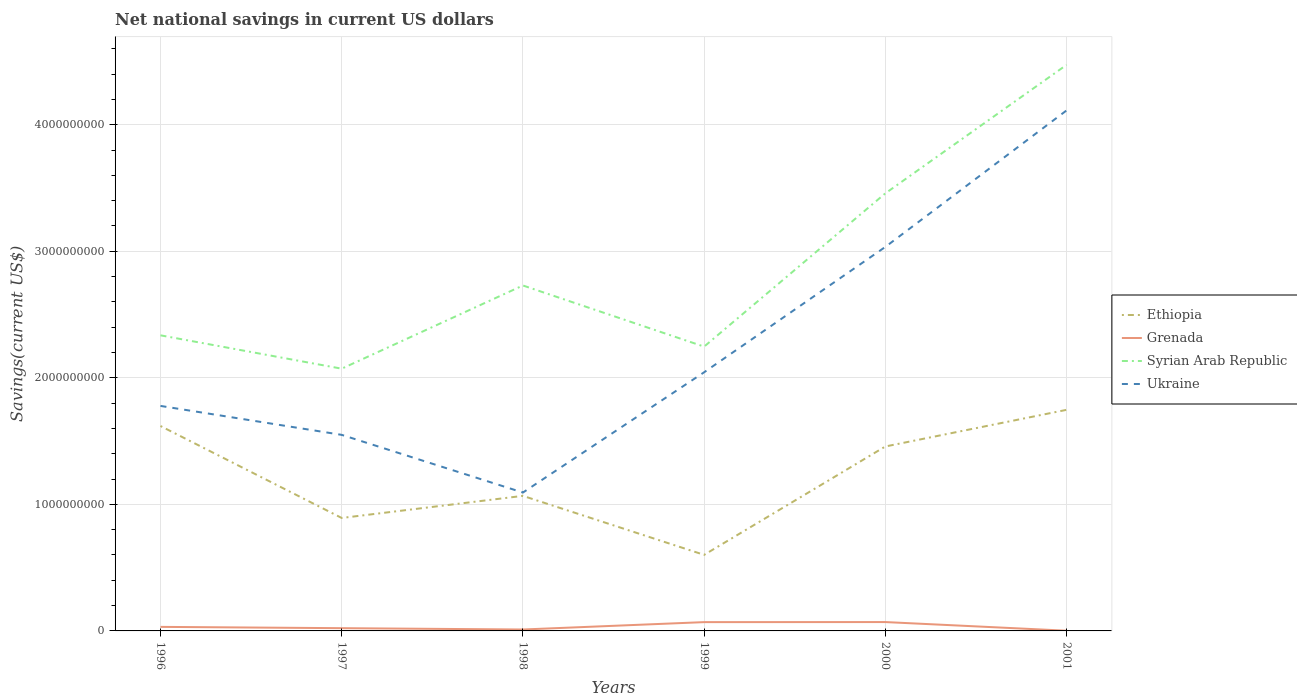Does the line corresponding to Grenada intersect with the line corresponding to Ethiopia?
Keep it short and to the point. No. Across all years, what is the maximum net national savings in Ethiopia?
Keep it short and to the point. 6.01e+08. In which year was the net national savings in Ukraine maximum?
Ensure brevity in your answer.  1998. What is the total net national savings in Grenada in the graph?
Give a very brief answer. 1.04e+07. What is the difference between the highest and the second highest net national savings in Grenada?
Provide a short and direct response. 6.84e+07. What is the difference between the highest and the lowest net national savings in Grenada?
Make the answer very short. 2. How many lines are there?
Offer a terse response. 4. How many years are there in the graph?
Ensure brevity in your answer.  6. Are the values on the major ticks of Y-axis written in scientific E-notation?
Offer a terse response. No. Does the graph contain any zero values?
Offer a very short reply. No. Does the graph contain grids?
Provide a succinct answer. Yes. Where does the legend appear in the graph?
Provide a short and direct response. Center right. How many legend labels are there?
Ensure brevity in your answer.  4. What is the title of the graph?
Your answer should be very brief. Net national savings in current US dollars. What is the label or title of the X-axis?
Ensure brevity in your answer.  Years. What is the label or title of the Y-axis?
Your answer should be compact. Savings(current US$). What is the Savings(current US$) of Ethiopia in 1996?
Make the answer very short. 1.62e+09. What is the Savings(current US$) of Grenada in 1996?
Provide a succinct answer. 3.20e+07. What is the Savings(current US$) of Syrian Arab Republic in 1996?
Give a very brief answer. 2.34e+09. What is the Savings(current US$) in Ukraine in 1996?
Make the answer very short. 1.78e+09. What is the Savings(current US$) of Ethiopia in 1997?
Offer a very short reply. 8.93e+08. What is the Savings(current US$) of Grenada in 1997?
Your answer should be very brief. 2.17e+07. What is the Savings(current US$) in Syrian Arab Republic in 1997?
Keep it short and to the point. 2.07e+09. What is the Savings(current US$) in Ukraine in 1997?
Ensure brevity in your answer.  1.55e+09. What is the Savings(current US$) of Ethiopia in 1998?
Your response must be concise. 1.07e+09. What is the Savings(current US$) of Grenada in 1998?
Make the answer very short. 1.13e+07. What is the Savings(current US$) of Syrian Arab Republic in 1998?
Make the answer very short. 2.73e+09. What is the Savings(current US$) in Ukraine in 1998?
Give a very brief answer. 1.09e+09. What is the Savings(current US$) in Ethiopia in 1999?
Your answer should be compact. 6.01e+08. What is the Savings(current US$) in Grenada in 1999?
Make the answer very short. 6.95e+07. What is the Savings(current US$) in Syrian Arab Republic in 1999?
Offer a very short reply. 2.25e+09. What is the Savings(current US$) in Ukraine in 1999?
Provide a short and direct response. 2.04e+09. What is the Savings(current US$) in Ethiopia in 2000?
Provide a succinct answer. 1.46e+09. What is the Savings(current US$) of Grenada in 2000?
Offer a terse response. 7.00e+07. What is the Savings(current US$) of Syrian Arab Republic in 2000?
Your answer should be very brief. 3.46e+09. What is the Savings(current US$) in Ukraine in 2000?
Offer a terse response. 3.03e+09. What is the Savings(current US$) of Ethiopia in 2001?
Give a very brief answer. 1.75e+09. What is the Savings(current US$) in Grenada in 2001?
Provide a succinct answer. 1.69e+06. What is the Savings(current US$) in Syrian Arab Republic in 2001?
Make the answer very short. 4.47e+09. What is the Savings(current US$) of Ukraine in 2001?
Your answer should be compact. 4.11e+09. Across all years, what is the maximum Savings(current US$) in Ethiopia?
Provide a succinct answer. 1.75e+09. Across all years, what is the maximum Savings(current US$) in Grenada?
Provide a succinct answer. 7.00e+07. Across all years, what is the maximum Savings(current US$) of Syrian Arab Republic?
Give a very brief answer. 4.47e+09. Across all years, what is the maximum Savings(current US$) of Ukraine?
Make the answer very short. 4.11e+09. Across all years, what is the minimum Savings(current US$) of Ethiopia?
Make the answer very short. 6.01e+08. Across all years, what is the minimum Savings(current US$) in Grenada?
Offer a terse response. 1.69e+06. Across all years, what is the minimum Savings(current US$) of Syrian Arab Republic?
Offer a very short reply. 2.07e+09. Across all years, what is the minimum Savings(current US$) in Ukraine?
Offer a very short reply. 1.09e+09. What is the total Savings(current US$) of Ethiopia in the graph?
Keep it short and to the point. 7.38e+09. What is the total Savings(current US$) of Grenada in the graph?
Keep it short and to the point. 2.06e+08. What is the total Savings(current US$) of Syrian Arab Republic in the graph?
Give a very brief answer. 1.73e+1. What is the total Savings(current US$) of Ukraine in the graph?
Offer a terse response. 1.36e+1. What is the difference between the Savings(current US$) of Ethiopia in 1996 and that in 1997?
Your answer should be compact. 7.27e+08. What is the difference between the Savings(current US$) in Grenada in 1996 and that in 1997?
Your answer should be very brief. 1.03e+07. What is the difference between the Savings(current US$) in Syrian Arab Republic in 1996 and that in 1997?
Provide a succinct answer. 2.64e+08. What is the difference between the Savings(current US$) of Ukraine in 1996 and that in 1997?
Your response must be concise. 2.29e+08. What is the difference between the Savings(current US$) of Ethiopia in 1996 and that in 1998?
Make the answer very short. 5.52e+08. What is the difference between the Savings(current US$) of Grenada in 1996 and that in 1998?
Provide a succinct answer. 2.07e+07. What is the difference between the Savings(current US$) in Syrian Arab Republic in 1996 and that in 1998?
Provide a short and direct response. -3.94e+08. What is the difference between the Savings(current US$) in Ukraine in 1996 and that in 1998?
Provide a short and direct response. 6.85e+08. What is the difference between the Savings(current US$) of Ethiopia in 1996 and that in 1999?
Your response must be concise. 1.02e+09. What is the difference between the Savings(current US$) of Grenada in 1996 and that in 1999?
Make the answer very short. -3.75e+07. What is the difference between the Savings(current US$) of Syrian Arab Republic in 1996 and that in 1999?
Ensure brevity in your answer.  8.92e+07. What is the difference between the Savings(current US$) in Ukraine in 1996 and that in 1999?
Your response must be concise. -2.66e+08. What is the difference between the Savings(current US$) in Ethiopia in 1996 and that in 2000?
Ensure brevity in your answer.  1.62e+08. What is the difference between the Savings(current US$) in Grenada in 1996 and that in 2000?
Offer a very short reply. -3.80e+07. What is the difference between the Savings(current US$) of Syrian Arab Republic in 1996 and that in 2000?
Offer a very short reply. -1.12e+09. What is the difference between the Savings(current US$) of Ukraine in 1996 and that in 2000?
Your response must be concise. -1.26e+09. What is the difference between the Savings(current US$) in Ethiopia in 1996 and that in 2001?
Give a very brief answer. -1.28e+08. What is the difference between the Savings(current US$) in Grenada in 1996 and that in 2001?
Your response must be concise. 3.03e+07. What is the difference between the Savings(current US$) in Syrian Arab Republic in 1996 and that in 2001?
Your answer should be very brief. -2.14e+09. What is the difference between the Savings(current US$) of Ukraine in 1996 and that in 2001?
Your answer should be very brief. -2.33e+09. What is the difference between the Savings(current US$) of Ethiopia in 1997 and that in 1998?
Make the answer very short. -1.75e+08. What is the difference between the Savings(current US$) of Grenada in 1997 and that in 1998?
Make the answer very short. 1.04e+07. What is the difference between the Savings(current US$) in Syrian Arab Republic in 1997 and that in 1998?
Keep it short and to the point. -6.57e+08. What is the difference between the Savings(current US$) of Ukraine in 1997 and that in 1998?
Offer a very short reply. 4.56e+08. What is the difference between the Savings(current US$) in Ethiopia in 1997 and that in 1999?
Your answer should be very brief. 2.92e+08. What is the difference between the Savings(current US$) of Grenada in 1997 and that in 1999?
Provide a short and direct response. -4.78e+07. What is the difference between the Savings(current US$) of Syrian Arab Republic in 1997 and that in 1999?
Make the answer very short. -1.74e+08. What is the difference between the Savings(current US$) in Ukraine in 1997 and that in 1999?
Provide a succinct answer. -4.95e+08. What is the difference between the Savings(current US$) in Ethiopia in 1997 and that in 2000?
Provide a succinct answer. -5.65e+08. What is the difference between the Savings(current US$) in Grenada in 1997 and that in 2000?
Keep it short and to the point. -4.84e+07. What is the difference between the Savings(current US$) in Syrian Arab Republic in 1997 and that in 2000?
Offer a very short reply. -1.39e+09. What is the difference between the Savings(current US$) of Ukraine in 1997 and that in 2000?
Provide a succinct answer. -1.49e+09. What is the difference between the Savings(current US$) in Ethiopia in 1997 and that in 2001?
Your answer should be compact. -8.54e+08. What is the difference between the Savings(current US$) in Grenada in 1997 and that in 2001?
Keep it short and to the point. 2.00e+07. What is the difference between the Savings(current US$) in Syrian Arab Republic in 1997 and that in 2001?
Offer a very short reply. -2.40e+09. What is the difference between the Savings(current US$) of Ukraine in 1997 and that in 2001?
Your answer should be compact. -2.56e+09. What is the difference between the Savings(current US$) of Ethiopia in 1998 and that in 1999?
Your response must be concise. 4.66e+08. What is the difference between the Savings(current US$) of Grenada in 1998 and that in 1999?
Ensure brevity in your answer.  -5.83e+07. What is the difference between the Savings(current US$) in Syrian Arab Republic in 1998 and that in 1999?
Your answer should be very brief. 4.83e+08. What is the difference between the Savings(current US$) of Ukraine in 1998 and that in 1999?
Offer a very short reply. -9.50e+08. What is the difference between the Savings(current US$) in Ethiopia in 1998 and that in 2000?
Provide a short and direct response. -3.90e+08. What is the difference between the Savings(current US$) in Grenada in 1998 and that in 2000?
Your answer should be very brief. -5.88e+07. What is the difference between the Savings(current US$) of Syrian Arab Republic in 1998 and that in 2000?
Make the answer very short. -7.28e+08. What is the difference between the Savings(current US$) in Ukraine in 1998 and that in 2000?
Make the answer very short. -1.94e+09. What is the difference between the Savings(current US$) of Ethiopia in 1998 and that in 2001?
Make the answer very short. -6.80e+08. What is the difference between the Savings(current US$) in Grenada in 1998 and that in 2001?
Your answer should be compact. 9.57e+06. What is the difference between the Savings(current US$) of Syrian Arab Republic in 1998 and that in 2001?
Offer a very short reply. -1.74e+09. What is the difference between the Savings(current US$) of Ukraine in 1998 and that in 2001?
Provide a short and direct response. -3.02e+09. What is the difference between the Savings(current US$) in Ethiopia in 1999 and that in 2000?
Give a very brief answer. -8.56e+08. What is the difference between the Savings(current US$) of Grenada in 1999 and that in 2000?
Your answer should be very brief. -5.31e+05. What is the difference between the Savings(current US$) of Syrian Arab Republic in 1999 and that in 2000?
Ensure brevity in your answer.  -1.21e+09. What is the difference between the Savings(current US$) of Ukraine in 1999 and that in 2000?
Ensure brevity in your answer.  -9.90e+08. What is the difference between the Savings(current US$) in Ethiopia in 1999 and that in 2001?
Your answer should be compact. -1.15e+09. What is the difference between the Savings(current US$) in Grenada in 1999 and that in 2001?
Keep it short and to the point. 6.78e+07. What is the difference between the Savings(current US$) in Syrian Arab Republic in 1999 and that in 2001?
Your response must be concise. -2.23e+09. What is the difference between the Savings(current US$) of Ukraine in 1999 and that in 2001?
Your response must be concise. -2.07e+09. What is the difference between the Savings(current US$) in Ethiopia in 2000 and that in 2001?
Provide a succinct answer. -2.90e+08. What is the difference between the Savings(current US$) in Grenada in 2000 and that in 2001?
Provide a succinct answer. 6.84e+07. What is the difference between the Savings(current US$) in Syrian Arab Republic in 2000 and that in 2001?
Make the answer very short. -1.02e+09. What is the difference between the Savings(current US$) of Ukraine in 2000 and that in 2001?
Your response must be concise. -1.08e+09. What is the difference between the Savings(current US$) of Ethiopia in 1996 and the Savings(current US$) of Grenada in 1997?
Give a very brief answer. 1.60e+09. What is the difference between the Savings(current US$) of Ethiopia in 1996 and the Savings(current US$) of Syrian Arab Republic in 1997?
Offer a terse response. -4.53e+08. What is the difference between the Savings(current US$) of Ethiopia in 1996 and the Savings(current US$) of Ukraine in 1997?
Give a very brief answer. 7.00e+07. What is the difference between the Savings(current US$) in Grenada in 1996 and the Savings(current US$) in Syrian Arab Republic in 1997?
Make the answer very short. -2.04e+09. What is the difference between the Savings(current US$) in Grenada in 1996 and the Savings(current US$) in Ukraine in 1997?
Give a very brief answer. -1.52e+09. What is the difference between the Savings(current US$) in Syrian Arab Republic in 1996 and the Savings(current US$) in Ukraine in 1997?
Provide a short and direct response. 7.86e+08. What is the difference between the Savings(current US$) of Ethiopia in 1996 and the Savings(current US$) of Grenada in 1998?
Provide a succinct answer. 1.61e+09. What is the difference between the Savings(current US$) of Ethiopia in 1996 and the Savings(current US$) of Syrian Arab Republic in 1998?
Your answer should be compact. -1.11e+09. What is the difference between the Savings(current US$) in Ethiopia in 1996 and the Savings(current US$) in Ukraine in 1998?
Offer a terse response. 5.26e+08. What is the difference between the Savings(current US$) of Grenada in 1996 and the Savings(current US$) of Syrian Arab Republic in 1998?
Provide a succinct answer. -2.70e+09. What is the difference between the Savings(current US$) of Grenada in 1996 and the Savings(current US$) of Ukraine in 1998?
Ensure brevity in your answer.  -1.06e+09. What is the difference between the Savings(current US$) of Syrian Arab Republic in 1996 and the Savings(current US$) of Ukraine in 1998?
Your response must be concise. 1.24e+09. What is the difference between the Savings(current US$) in Ethiopia in 1996 and the Savings(current US$) in Grenada in 1999?
Make the answer very short. 1.55e+09. What is the difference between the Savings(current US$) of Ethiopia in 1996 and the Savings(current US$) of Syrian Arab Republic in 1999?
Your response must be concise. -6.27e+08. What is the difference between the Savings(current US$) in Ethiopia in 1996 and the Savings(current US$) in Ukraine in 1999?
Ensure brevity in your answer.  -4.25e+08. What is the difference between the Savings(current US$) of Grenada in 1996 and the Savings(current US$) of Syrian Arab Republic in 1999?
Offer a very short reply. -2.21e+09. What is the difference between the Savings(current US$) in Grenada in 1996 and the Savings(current US$) in Ukraine in 1999?
Your response must be concise. -2.01e+09. What is the difference between the Savings(current US$) of Syrian Arab Republic in 1996 and the Savings(current US$) of Ukraine in 1999?
Make the answer very short. 2.92e+08. What is the difference between the Savings(current US$) of Ethiopia in 1996 and the Savings(current US$) of Grenada in 2000?
Give a very brief answer. 1.55e+09. What is the difference between the Savings(current US$) in Ethiopia in 1996 and the Savings(current US$) in Syrian Arab Republic in 2000?
Offer a terse response. -1.84e+09. What is the difference between the Savings(current US$) in Ethiopia in 1996 and the Savings(current US$) in Ukraine in 2000?
Give a very brief answer. -1.42e+09. What is the difference between the Savings(current US$) in Grenada in 1996 and the Savings(current US$) in Syrian Arab Republic in 2000?
Give a very brief answer. -3.43e+09. What is the difference between the Savings(current US$) in Grenada in 1996 and the Savings(current US$) in Ukraine in 2000?
Keep it short and to the point. -3.00e+09. What is the difference between the Savings(current US$) of Syrian Arab Republic in 1996 and the Savings(current US$) of Ukraine in 2000?
Make the answer very short. -6.99e+08. What is the difference between the Savings(current US$) in Ethiopia in 1996 and the Savings(current US$) in Grenada in 2001?
Your response must be concise. 1.62e+09. What is the difference between the Savings(current US$) in Ethiopia in 1996 and the Savings(current US$) in Syrian Arab Republic in 2001?
Provide a short and direct response. -2.85e+09. What is the difference between the Savings(current US$) in Ethiopia in 1996 and the Savings(current US$) in Ukraine in 2001?
Your response must be concise. -2.49e+09. What is the difference between the Savings(current US$) in Grenada in 1996 and the Savings(current US$) in Syrian Arab Republic in 2001?
Provide a short and direct response. -4.44e+09. What is the difference between the Savings(current US$) in Grenada in 1996 and the Savings(current US$) in Ukraine in 2001?
Give a very brief answer. -4.08e+09. What is the difference between the Savings(current US$) of Syrian Arab Republic in 1996 and the Savings(current US$) of Ukraine in 2001?
Your answer should be compact. -1.78e+09. What is the difference between the Savings(current US$) in Ethiopia in 1997 and the Savings(current US$) in Grenada in 1998?
Keep it short and to the point. 8.81e+08. What is the difference between the Savings(current US$) in Ethiopia in 1997 and the Savings(current US$) in Syrian Arab Republic in 1998?
Your answer should be compact. -1.84e+09. What is the difference between the Savings(current US$) in Ethiopia in 1997 and the Savings(current US$) in Ukraine in 1998?
Give a very brief answer. -2.01e+08. What is the difference between the Savings(current US$) in Grenada in 1997 and the Savings(current US$) in Syrian Arab Republic in 1998?
Ensure brevity in your answer.  -2.71e+09. What is the difference between the Savings(current US$) of Grenada in 1997 and the Savings(current US$) of Ukraine in 1998?
Offer a terse response. -1.07e+09. What is the difference between the Savings(current US$) in Syrian Arab Republic in 1997 and the Savings(current US$) in Ukraine in 1998?
Provide a short and direct response. 9.79e+08. What is the difference between the Savings(current US$) of Ethiopia in 1997 and the Savings(current US$) of Grenada in 1999?
Provide a short and direct response. 8.23e+08. What is the difference between the Savings(current US$) of Ethiopia in 1997 and the Savings(current US$) of Syrian Arab Republic in 1999?
Your answer should be compact. -1.35e+09. What is the difference between the Savings(current US$) of Ethiopia in 1997 and the Savings(current US$) of Ukraine in 1999?
Your answer should be compact. -1.15e+09. What is the difference between the Savings(current US$) of Grenada in 1997 and the Savings(current US$) of Syrian Arab Republic in 1999?
Ensure brevity in your answer.  -2.22e+09. What is the difference between the Savings(current US$) in Grenada in 1997 and the Savings(current US$) in Ukraine in 1999?
Make the answer very short. -2.02e+09. What is the difference between the Savings(current US$) of Syrian Arab Republic in 1997 and the Savings(current US$) of Ukraine in 1999?
Ensure brevity in your answer.  2.83e+07. What is the difference between the Savings(current US$) of Ethiopia in 1997 and the Savings(current US$) of Grenada in 2000?
Provide a succinct answer. 8.22e+08. What is the difference between the Savings(current US$) of Ethiopia in 1997 and the Savings(current US$) of Syrian Arab Republic in 2000?
Keep it short and to the point. -2.57e+09. What is the difference between the Savings(current US$) of Ethiopia in 1997 and the Savings(current US$) of Ukraine in 2000?
Provide a short and direct response. -2.14e+09. What is the difference between the Savings(current US$) in Grenada in 1997 and the Savings(current US$) in Syrian Arab Republic in 2000?
Your answer should be very brief. -3.44e+09. What is the difference between the Savings(current US$) in Grenada in 1997 and the Savings(current US$) in Ukraine in 2000?
Make the answer very short. -3.01e+09. What is the difference between the Savings(current US$) of Syrian Arab Republic in 1997 and the Savings(current US$) of Ukraine in 2000?
Ensure brevity in your answer.  -9.62e+08. What is the difference between the Savings(current US$) of Ethiopia in 1997 and the Savings(current US$) of Grenada in 2001?
Offer a terse response. 8.91e+08. What is the difference between the Savings(current US$) in Ethiopia in 1997 and the Savings(current US$) in Syrian Arab Republic in 2001?
Your response must be concise. -3.58e+09. What is the difference between the Savings(current US$) in Ethiopia in 1997 and the Savings(current US$) in Ukraine in 2001?
Offer a terse response. -3.22e+09. What is the difference between the Savings(current US$) in Grenada in 1997 and the Savings(current US$) in Syrian Arab Republic in 2001?
Your response must be concise. -4.45e+09. What is the difference between the Savings(current US$) in Grenada in 1997 and the Savings(current US$) in Ukraine in 2001?
Ensure brevity in your answer.  -4.09e+09. What is the difference between the Savings(current US$) in Syrian Arab Republic in 1997 and the Savings(current US$) in Ukraine in 2001?
Your answer should be compact. -2.04e+09. What is the difference between the Savings(current US$) in Ethiopia in 1998 and the Savings(current US$) in Grenada in 1999?
Ensure brevity in your answer.  9.98e+08. What is the difference between the Savings(current US$) of Ethiopia in 1998 and the Savings(current US$) of Syrian Arab Republic in 1999?
Make the answer very short. -1.18e+09. What is the difference between the Savings(current US$) in Ethiopia in 1998 and the Savings(current US$) in Ukraine in 1999?
Your answer should be compact. -9.77e+08. What is the difference between the Savings(current US$) in Grenada in 1998 and the Savings(current US$) in Syrian Arab Republic in 1999?
Ensure brevity in your answer.  -2.24e+09. What is the difference between the Savings(current US$) of Grenada in 1998 and the Savings(current US$) of Ukraine in 1999?
Your response must be concise. -2.03e+09. What is the difference between the Savings(current US$) of Syrian Arab Republic in 1998 and the Savings(current US$) of Ukraine in 1999?
Provide a short and direct response. 6.86e+08. What is the difference between the Savings(current US$) in Ethiopia in 1998 and the Savings(current US$) in Grenada in 2000?
Ensure brevity in your answer.  9.97e+08. What is the difference between the Savings(current US$) in Ethiopia in 1998 and the Savings(current US$) in Syrian Arab Republic in 2000?
Your response must be concise. -2.39e+09. What is the difference between the Savings(current US$) of Ethiopia in 1998 and the Savings(current US$) of Ukraine in 2000?
Provide a succinct answer. -1.97e+09. What is the difference between the Savings(current US$) of Grenada in 1998 and the Savings(current US$) of Syrian Arab Republic in 2000?
Offer a terse response. -3.45e+09. What is the difference between the Savings(current US$) of Grenada in 1998 and the Savings(current US$) of Ukraine in 2000?
Ensure brevity in your answer.  -3.02e+09. What is the difference between the Savings(current US$) in Syrian Arab Republic in 1998 and the Savings(current US$) in Ukraine in 2000?
Give a very brief answer. -3.05e+08. What is the difference between the Savings(current US$) of Ethiopia in 1998 and the Savings(current US$) of Grenada in 2001?
Your answer should be very brief. 1.07e+09. What is the difference between the Savings(current US$) of Ethiopia in 1998 and the Savings(current US$) of Syrian Arab Republic in 2001?
Offer a terse response. -3.41e+09. What is the difference between the Savings(current US$) of Ethiopia in 1998 and the Savings(current US$) of Ukraine in 2001?
Give a very brief answer. -3.05e+09. What is the difference between the Savings(current US$) of Grenada in 1998 and the Savings(current US$) of Syrian Arab Republic in 2001?
Make the answer very short. -4.46e+09. What is the difference between the Savings(current US$) of Grenada in 1998 and the Savings(current US$) of Ukraine in 2001?
Offer a very short reply. -4.10e+09. What is the difference between the Savings(current US$) of Syrian Arab Republic in 1998 and the Savings(current US$) of Ukraine in 2001?
Keep it short and to the point. -1.38e+09. What is the difference between the Savings(current US$) in Ethiopia in 1999 and the Savings(current US$) in Grenada in 2000?
Your response must be concise. 5.31e+08. What is the difference between the Savings(current US$) of Ethiopia in 1999 and the Savings(current US$) of Syrian Arab Republic in 2000?
Your response must be concise. -2.86e+09. What is the difference between the Savings(current US$) in Ethiopia in 1999 and the Savings(current US$) in Ukraine in 2000?
Your response must be concise. -2.43e+09. What is the difference between the Savings(current US$) in Grenada in 1999 and the Savings(current US$) in Syrian Arab Republic in 2000?
Give a very brief answer. -3.39e+09. What is the difference between the Savings(current US$) of Grenada in 1999 and the Savings(current US$) of Ukraine in 2000?
Keep it short and to the point. -2.96e+09. What is the difference between the Savings(current US$) of Syrian Arab Republic in 1999 and the Savings(current US$) of Ukraine in 2000?
Provide a short and direct response. -7.88e+08. What is the difference between the Savings(current US$) of Ethiopia in 1999 and the Savings(current US$) of Grenada in 2001?
Give a very brief answer. 5.99e+08. What is the difference between the Savings(current US$) of Ethiopia in 1999 and the Savings(current US$) of Syrian Arab Republic in 2001?
Give a very brief answer. -3.87e+09. What is the difference between the Savings(current US$) of Ethiopia in 1999 and the Savings(current US$) of Ukraine in 2001?
Make the answer very short. -3.51e+09. What is the difference between the Savings(current US$) of Grenada in 1999 and the Savings(current US$) of Syrian Arab Republic in 2001?
Your answer should be very brief. -4.40e+09. What is the difference between the Savings(current US$) in Grenada in 1999 and the Savings(current US$) in Ukraine in 2001?
Offer a very short reply. -4.04e+09. What is the difference between the Savings(current US$) in Syrian Arab Republic in 1999 and the Savings(current US$) in Ukraine in 2001?
Your answer should be very brief. -1.87e+09. What is the difference between the Savings(current US$) of Ethiopia in 2000 and the Savings(current US$) of Grenada in 2001?
Keep it short and to the point. 1.46e+09. What is the difference between the Savings(current US$) in Ethiopia in 2000 and the Savings(current US$) in Syrian Arab Republic in 2001?
Offer a terse response. -3.02e+09. What is the difference between the Savings(current US$) in Ethiopia in 2000 and the Savings(current US$) in Ukraine in 2001?
Your response must be concise. -2.66e+09. What is the difference between the Savings(current US$) in Grenada in 2000 and the Savings(current US$) in Syrian Arab Republic in 2001?
Make the answer very short. -4.40e+09. What is the difference between the Savings(current US$) of Grenada in 2000 and the Savings(current US$) of Ukraine in 2001?
Your response must be concise. -4.04e+09. What is the difference between the Savings(current US$) in Syrian Arab Republic in 2000 and the Savings(current US$) in Ukraine in 2001?
Your response must be concise. -6.55e+08. What is the average Savings(current US$) of Ethiopia per year?
Your answer should be compact. 1.23e+09. What is the average Savings(current US$) in Grenada per year?
Your answer should be compact. 3.44e+07. What is the average Savings(current US$) in Syrian Arab Republic per year?
Make the answer very short. 2.89e+09. What is the average Savings(current US$) of Ukraine per year?
Offer a very short reply. 2.27e+09. In the year 1996, what is the difference between the Savings(current US$) of Ethiopia and Savings(current US$) of Grenada?
Provide a short and direct response. 1.59e+09. In the year 1996, what is the difference between the Savings(current US$) in Ethiopia and Savings(current US$) in Syrian Arab Republic?
Keep it short and to the point. -7.16e+08. In the year 1996, what is the difference between the Savings(current US$) in Ethiopia and Savings(current US$) in Ukraine?
Your answer should be compact. -1.59e+08. In the year 1996, what is the difference between the Savings(current US$) of Grenada and Savings(current US$) of Syrian Arab Republic?
Your response must be concise. -2.30e+09. In the year 1996, what is the difference between the Savings(current US$) in Grenada and Savings(current US$) in Ukraine?
Your answer should be compact. -1.75e+09. In the year 1996, what is the difference between the Savings(current US$) of Syrian Arab Republic and Savings(current US$) of Ukraine?
Offer a terse response. 5.58e+08. In the year 1997, what is the difference between the Savings(current US$) in Ethiopia and Savings(current US$) in Grenada?
Make the answer very short. 8.71e+08. In the year 1997, what is the difference between the Savings(current US$) in Ethiopia and Savings(current US$) in Syrian Arab Republic?
Keep it short and to the point. -1.18e+09. In the year 1997, what is the difference between the Savings(current US$) in Ethiopia and Savings(current US$) in Ukraine?
Your answer should be very brief. -6.57e+08. In the year 1997, what is the difference between the Savings(current US$) of Grenada and Savings(current US$) of Syrian Arab Republic?
Your answer should be compact. -2.05e+09. In the year 1997, what is the difference between the Savings(current US$) of Grenada and Savings(current US$) of Ukraine?
Ensure brevity in your answer.  -1.53e+09. In the year 1997, what is the difference between the Savings(current US$) in Syrian Arab Republic and Savings(current US$) in Ukraine?
Provide a succinct answer. 5.23e+08. In the year 1998, what is the difference between the Savings(current US$) in Ethiopia and Savings(current US$) in Grenada?
Your answer should be very brief. 1.06e+09. In the year 1998, what is the difference between the Savings(current US$) in Ethiopia and Savings(current US$) in Syrian Arab Republic?
Offer a terse response. -1.66e+09. In the year 1998, what is the difference between the Savings(current US$) of Ethiopia and Savings(current US$) of Ukraine?
Provide a succinct answer. -2.62e+07. In the year 1998, what is the difference between the Savings(current US$) in Grenada and Savings(current US$) in Syrian Arab Republic?
Offer a terse response. -2.72e+09. In the year 1998, what is the difference between the Savings(current US$) of Grenada and Savings(current US$) of Ukraine?
Your response must be concise. -1.08e+09. In the year 1998, what is the difference between the Savings(current US$) of Syrian Arab Republic and Savings(current US$) of Ukraine?
Make the answer very short. 1.64e+09. In the year 1999, what is the difference between the Savings(current US$) of Ethiopia and Savings(current US$) of Grenada?
Provide a succinct answer. 5.32e+08. In the year 1999, what is the difference between the Savings(current US$) in Ethiopia and Savings(current US$) in Syrian Arab Republic?
Your answer should be very brief. -1.65e+09. In the year 1999, what is the difference between the Savings(current US$) in Ethiopia and Savings(current US$) in Ukraine?
Offer a terse response. -1.44e+09. In the year 1999, what is the difference between the Savings(current US$) in Grenada and Savings(current US$) in Syrian Arab Republic?
Keep it short and to the point. -2.18e+09. In the year 1999, what is the difference between the Savings(current US$) in Grenada and Savings(current US$) in Ukraine?
Make the answer very short. -1.97e+09. In the year 1999, what is the difference between the Savings(current US$) of Syrian Arab Republic and Savings(current US$) of Ukraine?
Provide a short and direct response. 2.03e+08. In the year 2000, what is the difference between the Savings(current US$) in Ethiopia and Savings(current US$) in Grenada?
Ensure brevity in your answer.  1.39e+09. In the year 2000, what is the difference between the Savings(current US$) in Ethiopia and Savings(current US$) in Syrian Arab Republic?
Your answer should be compact. -2.00e+09. In the year 2000, what is the difference between the Savings(current US$) in Ethiopia and Savings(current US$) in Ukraine?
Your answer should be compact. -1.58e+09. In the year 2000, what is the difference between the Savings(current US$) of Grenada and Savings(current US$) of Syrian Arab Republic?
Offer a very short reply. -3.39e+09. In the year 2000, what is the difference between the Savings(current US$) in Grenada and Savings(current US$) in Ukraine?
Your response must be concise. -2.96e+09. In the year 2000, what is the difference between the Savings(current US$) of Syrian Arab Republic and Savings(current US$) of Ukraine?
Provide a succinct answer. 4.23e+08. In the year 2001, what is the difference between the Savings(current US$) in Ethiopia and Savings(current US$) in Grenada?
Provide a succinct answer. 1.75e+09. In the year 2001, what is the difference between the Savings(current US$) in Ethiopia and Savings(current US$) in Syrian Arab Republic?
Provide a short and direct response. -2.73e+09. In the year 2001, what is the difference between the Savings(current US$) in Ethiopia and Savings(current US$) in Ukraine?
Keep it short and to the point. -2.37e+09. In the year 2001, what is the difference between the Savings(current US$) in Grenada and Savings(current US$) in Syrian Arab Republic?
Ensure brevity in your answer.  -4.47e+09. In the year 2001, what is the difference between the Savings(current US$) of Grenada and Savings(current US$) of Ukraine?
Your answer should be very brief. -4.11e+09. In the year 2001, what is the difference between the Savings(current US$) in Syrian Arab Republic and Savings(current US$) in Ukraine?
Keep it short and to the point. 3.60e+08. What is the ratio of the Savings(current US$) of Ethiopia in 1996 to that in 1997?
Offer a terse response. 1.81. What is the ratio of the Savings(current US$) in Grenada in 1996 to that in 1997?
Offer a terse response. 1.48. What is the ratio of the Savings(current US$) in Syrian Arab Republic in 1996 to that in 1997?
Your response must be concise. 1.13. What is the ratio of the Savings(current US$) in Ukraine in 1996 to that in 1997?
Offer a very short reply. 1.15. What is the ratio of the Savings(current US$) in Ethiopia in 1996 to that in 1998?
Provide a succinct answer. 1.52. What is the ratio of the Savings(current US$) in Grenada in 1996 to that in 1998?
Your response must be concise. 2.84. What is the ratio of the Savings(current US$) in Syrian Arab Republic in 1996 to that in 1998?
Provide a succinct answer. 0.86. What is the ratio of the Savings(current US$) of Ukraine in 1996 to that in 1998?
Offer a very short reply. 1.63. What is the ratio of the Savings(current US$) in Ethiopia in 1996 to that in 1999?
Make the answer very short. 2.69. What is the ratio of the Savings(current US$) in Grenada in 1996 to that in 1999?
Provide a succinct answer. 0.46. What is the ratio of the Savings(current US$) of Syrian Arab Republic in 1996 to that in 1999?
Provide a short and direct response. 1.04. What is the ratio of the Savings(current US$) of Ukraine in 1996 to that in 1999?
Your answer should be compact. 0.87. What is the ratio of the Savings(current US$) of Ethiopia in 1996 to that in 2000?
Give a very brief answer. 1.11. What is the ratio of the Savings(current US$) of Grenada in 1996 to that in 2000?
Your answer should be compact. 0.46. What is the ratio of the Savings(current US$) of Syrian Arab Republic in 1996 to that in 2000?
Your answer should be compact. 0.68. What is the ratio of the Savings(current US$) in Ukraine in 1996 to that in 2000?
Offer a terse response. 0.59. What is the ratio of the Savings(current US$) in Ethiopia in 1996 to that in 2001?
Offer a very short reply. 0.93. What is the ratio of the Savings(current US$) in Grenada in 1996 to that in 2001?
Give a very brief answer. 18.88. What is the ratio of the Savings(current US$) of Syrian Arab Republic in 1996 to that in 2001?
Your response must be concise. 0.52. What is the ratio of the Savings(current US$) of Ukraine in 1996 to that in 2001?
Provide a succinct answer. 0.43. What is the ratio of the Savings(current US$) of Ethiopia in 1997 to that in 1998?
Make the answer very short. 0.84. What is the ratio of the Savings(current US$) of Grenada in 1997 to that in 1998?
Your response must be concise. 1.93. What is the ratio of the Savings(current US$) in Syrian Arab Republic in 1997 to that in 1998?
Make the answer very short. 0.76. What is the ratio of the Savings(current US$) of Ukraine in 1997 to that in 1998?
Your answer should be very brief. 1.42. What is the ratio of the Savings(current US$) in Ethiopia in 1997 to that in 1999?
Make the answer very short. 1.49. What is the ratio of the Savings(current US$) in Grenada in 1997 to that in 1999?
Your answer should be very brief. 0.31. What is the ratio of the Savings(current US$) of Syrian Arab Republic in 1997 to that in 1999?
Your answer should be compact. 0.92. What is the ratio of the Savings(current US$) of Ukraine in 1997 to that in 1999?
Provide a short and direct response. 0.76. What is the ratio of the Savings(current US$) of Ethiopia in 1997 to that in 2000?
Make the answer very short. 0.61. What is the ratio of the Savings(current US$) of Grenada in 1997 to that in 2000?
Make the answer very short. 0.31. What is the ratio of the Savings(current US$) in Syrian Arab Republic in 1997 to that in 2000?
Your response must be concise. 0.6. What is the ratio of the Savings(current US$) of Ukraine in 1997 to that in 2000?
Your response must be concise. 0.51. What is the ratio of the Savings(current US$) of Ethiopia in 1997 to that in 2001?
Your response must be concise. 0.51. What is the ratio of the Savings(current US$) of Grenada in 1997 to that in 2001?
Keep it short and to the point. 12.8. What is the ratio of the Savings(current US$) in Syrian Arab Republic in 1997 to that in 2001?
Your response must be concise. 0.46. What is the ratio of the Savings(current US$) of Ukraine in 1997 to that in 2001?
Your answer should be compact. 0.38. What is the ratio of the Savings(current US$) of Ethiopia in 1998 to that in 1999?
Make the answer very short. 1.78. What is the ratio of the Savings(current US$) in Grenada in 1998 to that in 1999?
Offer a very short reply. 0.16. What is the ratio of the Savings(current US$) in Syrian Arab Republic in 1998 to that in 1999?
Give a very brief answer. 1.22. What is the ratio of the Savings(current US$) in Ukraine in 1998 to that in 1999?
Your response must be concise. 0.54. What is the ratio of the Savings(current US$) of Ethiopia in 1998 to that in 2000?
Offer a terse response. 0.73. What is the ratio of the Savings(current US$) of Grenada in 1998 to that in 2000?
Your response must be concise. 0.16. What is the ratio of the Savings(current US$) of Syrian Arab Republic in 1998 to that in 2000?
Your response must be concise. 0.79. What is the ratio of the Savings(current US$) in Ukraine in 1998 to that in 2000?
Ensure brevity in your answer.  0.36. What is the ratio of the Savings(current US$) of Ethiopia in 1998 to that in 2001?
Provide a succinct answer. 0.61. What is the ratio of the Savings(current US$) in Grenada in 1998 to that in 2001?
Keep it short and to the point. 6.64. What is the ratio of the Savings(current US$) in Syrian Arab Republic in 1998 to that in 2001?
Provide a succinct answer. 0.61. What is the ratio of the Savings(current US$) in Ukraine in 1998 to that in 2001?
Your answer should be compact. 0.27. What is the ratio of the Savings(current US$) in Ethiopia in 1999 to that in 2000?
Provide a short and direct response. 0.41. What is the ratio of the Savings(current US$) of Syrian Arab Republic in 1999 to that in 2000?
Offer a terse response. 0.65. What is the ratio of the Savings(current US$) in Ukraine in 1999 to that in 2000?
Give a very brief answer. 0.67. What is the ratio of the Savings(current US$) in Ethiopia in 1999 to that in 2001?
Offer a terse response. 0.34. What is the ratio of the Savings(current US$) in Grenada in 1999 to that in 2001?
Provide a short and direct response. 41.02. What is the ratio of the Savings(current US$) in Syrian Arab Republic in 1999 to that in 2001?
Provide a short and direct response. 0.5. What is the ratio of the Savings(current US$) of Ukraine in 1999 to that in 2001?
Ensure brevity in your answer.  0.5. What is the ratio of the Savings(current US$) in Ethiopia in 2000 to that in 2001?
Your answer should be compact. 0.83. What is the ratio of the Savings(current US$) in Grenada in 2000 to that in 2001?
Give a very brief answer. 41.33. What is the ratio of the Savings(current US$) in Syrian Arab Republic in 2000 to that in 2001?
Your answer should be compact. 0.77. What is the ratio of the Savings(current US$) in Ukraine in 2000 to that in 2001?
Offer a very short reply. 0.74. What is the difference between the highest and the second highest Savings(current US$) of Ethiopia?
Ensure brevity in your answer.  1.28e+08. What is the difference between the highest and the second highest Savings(current US$) of Grenada?
Your answer should be very brief. 5.31e+05. What is the difference between the highest and the second highest Savings(current US$) of Syrian Arab Republic?
Provide a succinct answer. 1.02e+09. What is the difference between the highest and the second highest Savings(current US$) in Ukraine?
Your answer should be compact. 1.08e+09. What is the difference between the highest and the lowest Savings(current US$) of Ethiopia?
Offer a terse response. 1.15e+09. What is the difference between the highest and the lowest Savings(current US$) of Grenada?
Provide a short and direct response. 6.84e+07. What is the difference between the highest and the lowest Savings(current US$) in Syrian Arab Republic?
Your answer should be compact. 2.40e+09. What is the difference between the highest and the lowest Savings(current US$) in Ukraine?
Provide a succinct answer. 3.02e+09. 